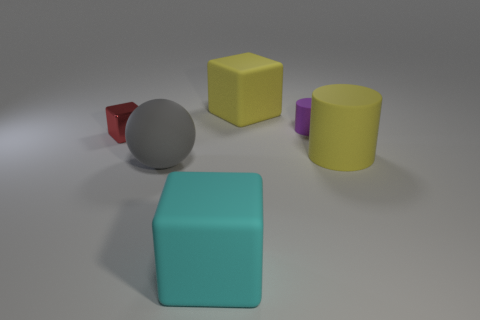Add 2 red objects. How many objects exist? 8 Subtract all spheres. How many objects are left? 5 Add 2 yellow objects. How many yellow objects exist? 4 Subtract 0 cyan spheres. How many objects are left? 6 Subtract all brown shiny spheres. Subtract all spheres. How many objects are left? 5 Add 6 gray matte balls. How many gray matte balls are left? 7 